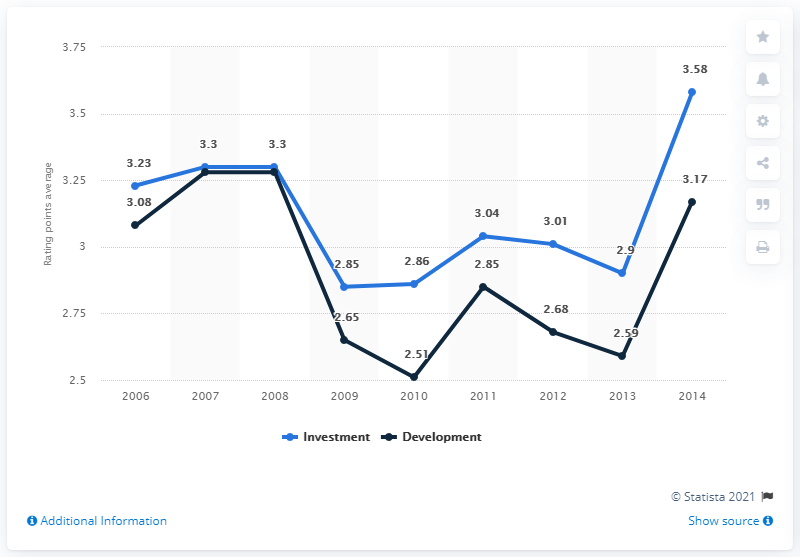Point out several critical features in this image. In 2014, the investment rating in Europe was 3.58. The average of the number 2012 is 2.845. For two years, the value of investment and development is the same. The real estate market of cities in Europe became increasingly attractive in the year 2014. 